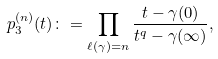Convert formula to latex. <formula><loc_0><loc_0><loc_500><loc_500>p _ { 3 } ^ { ( n ) } ( t ) \colon = \prod _ { \ell ( \gamma ) = n } \frac { t - \gamma ( 0 ) } { t ^ { q } - \gamma ( \infty ) } ,</formula> 